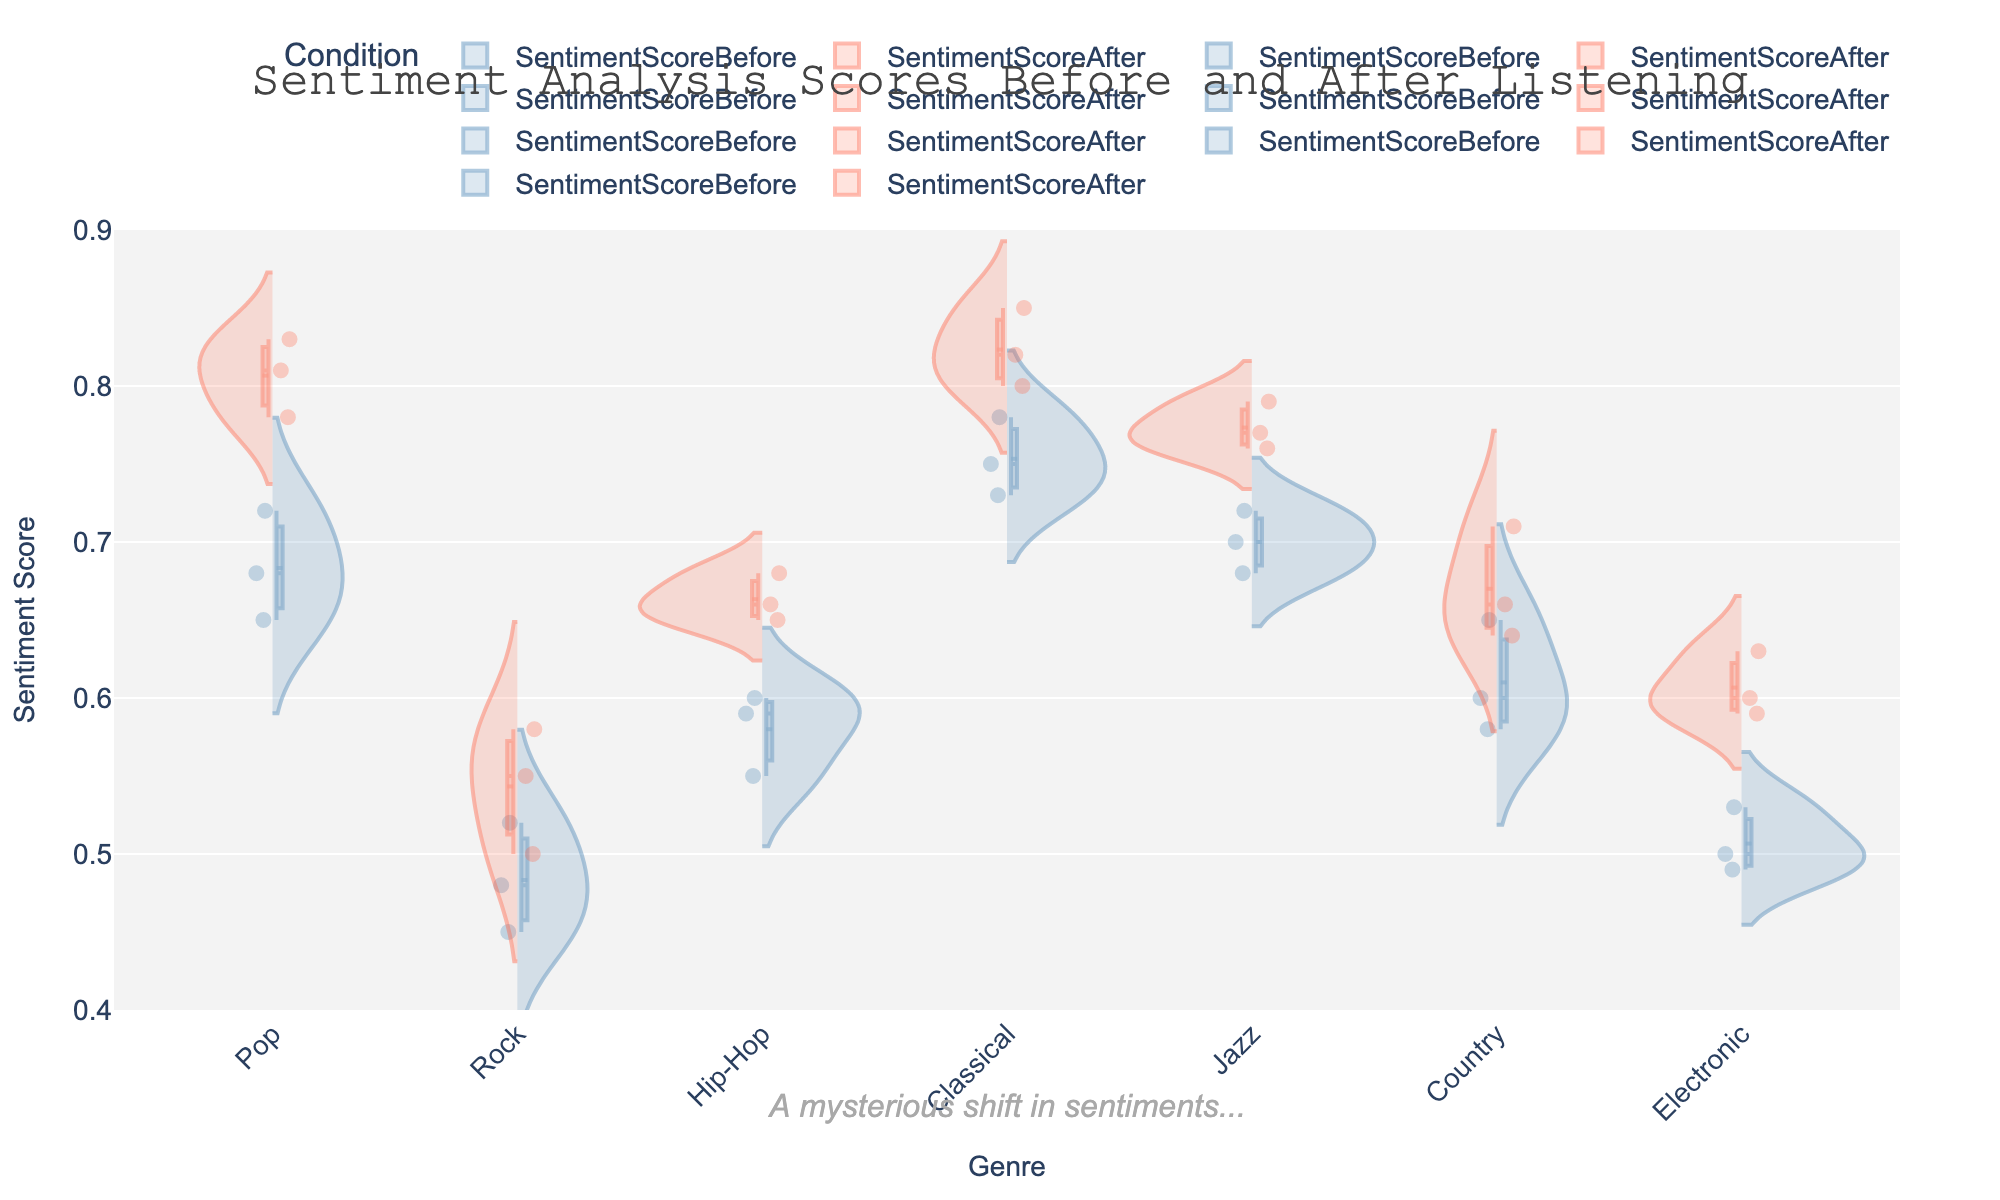What's the title of the figure? The title is displayed prominently at the top of the figure.
Answer: Sentiment Analysis Scores Before and After Listening What are the two conditions compared in the figure? Each genre has two sets of sentiment scores indicated by different styles on the violin plot.
Answer: SentimentScoreBefore and SentimentScoreAfter Which genre shows the highest median sentiment score after listening? By examining the violin plots for SentimentScoreAfter, Classical has the highest median line.
Answer: Classical Which genre shows the smallest increase in median sentiment score after listening? Compare the median lines before and after listening for each genre; Rock shows the smallest increase.
Answer: Rock How many data points are there for the Pop genre before listening? Count the individual points within the violin plot for the Pop genre on the positive side.
Answer: 3 What is the range of sentiment scores for the Hip-Hop genre before listening? Observe the highest and lowest points within the violin plot for Hip-Hop genre on the positive side.
Answer: 0.55 to 0.60 Which genre's sentiment scores have the broadest distribution after listening? The genre with the widest plot on the negative side indicates the broadest distribution.
Answer: Pop For which genre are the sentiment scores' boxes closer together, suggesting less variability? Check which genre's box plots are narrowest within the violin plots.
Answer: Classical Are there any outliers present in the sentiment scores before listening? If yes, specify the genre. Outliers are shown as individual points outside the whiskers in the box plot on the positive side.
Answer: No What is the annotation text in the figure? The annotation is added to provide additional context or commentary and is positioned below the figure.
Answer: A mysterious shift in sentiments.. 